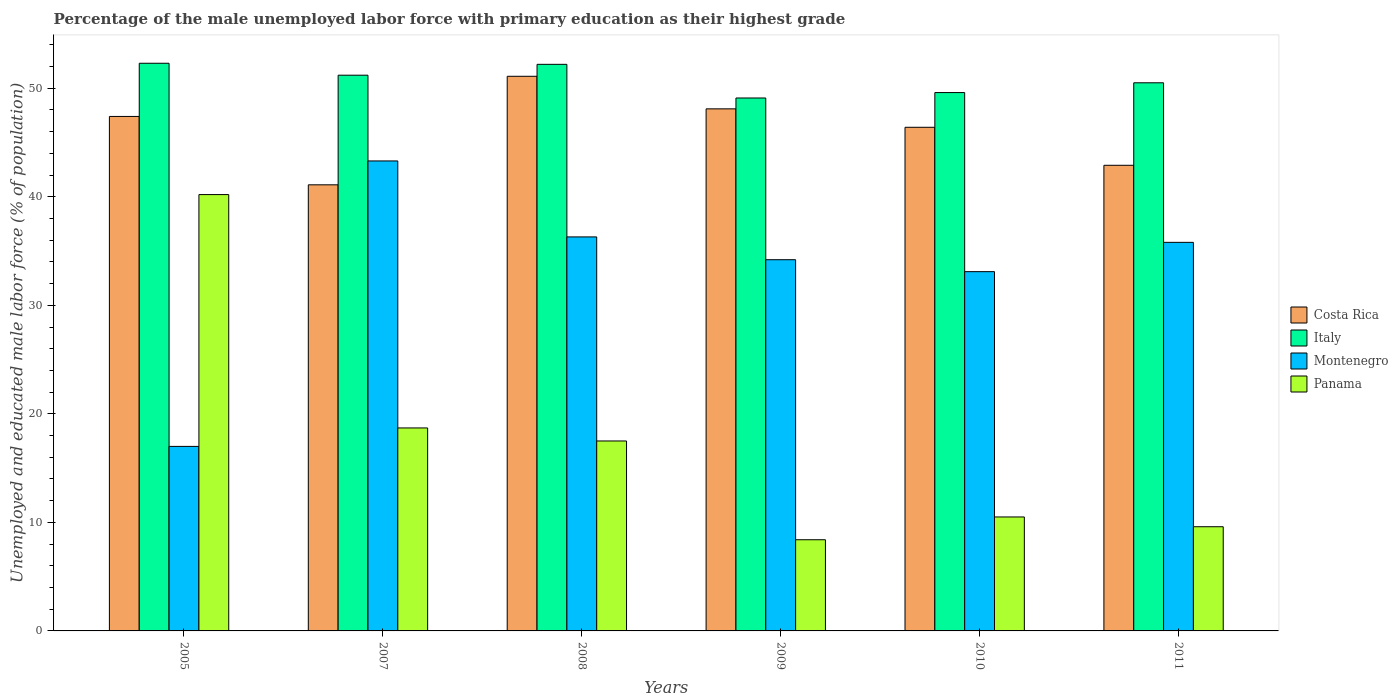How many different coloured bars are there?
Your answer should be compact. 4. How many groups of bars are there?
Your answer should be compact. 6. How many bars are there on the 2nd tick from the left?
Offer a very short reply. 4. What is the percentage of the unemployed male labor force with primary education in Italy in 2010?
Give a very brief answer. 49.6. Across all years, what is the maximum percentage of the unemployed male labor force with primary education in Montenegro?
Your answer should be compact. 43.3. Across all years, what is the minimum percentage of the unemployed male labor force with primary education in Montenegro?
Your answer should be very brief. 17. In which year was the percentage of the unemployed male labor force with primary education in Italy maximum?
Keep it short and to the point. 2005. What is the total percentage of the unemployed male labor force with primary education in Panama in the graph?
Your response must be concise. 104.9. What is the difference between the percentage of the unemployed male labor force with primary education in Panama in 2007 and that in 2008?
Provide a short and direct response. 1.2. What is the difference between the percentage of the unemployed male labor force with primary education in Panama in 2010 and the percentage of the unemployed male labor force with primary education in Italy in 2009?
Your answer should be very brief. -38.6. What is the average percentage of the unemployed male labor force with primary education in Montenegro per year?
Your answer should be very brief. 33.28. In the year 2009, what is the difference between the percentage of the unemployed male labor force with primary education in Italy and percentage of the unemployed male labor force with primary education in Costa Rica?
Your response must be concise. 1. In how many years, is the percentage of the unemployed male labor force with primary education in Panama greater than 34 %?
Keep it short and to the point. 1. What is the ratio of the percentage of the unemployed male labor force with primary education in Panama in 2010 to that in 2011?
Your answer should be compact. 1.09. What is the difference between the highest and the lowest percentage of the unemployed male labor force with primary education in Montenegro?
Give a very brief answer. 26.3. What does the 2nd bar from the left in 2009 represents?
Provide a short and direct response. Italy. How many bars are there?
Your response must be concise. 24. Are all the bars in the graph horizontal?
Provide a succinct answer. No. How many years are there in the graph?
Your response must be concise. 6. What is the difference between two consecutive major ticks on the Y-axis?
Ensure brevity in your answer.  10. Are the values on the major ticks of Y-axis written in scientific E-notation?
Your answer should be very brief. No. Does the graph contain grids?
Your response must be concise. No. How many legend labels are there?
Offer a terse response. 4. What is the title of the graph?
Provide a short and direct response. Percentage of the male unemployed labor force with primary education as their highest grade. What is the label or title of the X-axis?
Offer a very short reply. Years. What is the label or title of the Y-axis?
Provide a succinct answer. Unemployed and educated male labor force (% of population). What is the Unemployed and educated male labor force (% of population) in Costa Rica in 2005?
Offer a very short reply. 47.4. What is the Unemployed and educated male labor force (% of population) in Italy in 2005?
Your response must be concise. 52.3. What is the Unemployed and educated male labor force (% of population) in Montenegro in 2005?
Provide a short and direct response. 17. What is the Unemployed and educated male labor force (% of population) in Panama in 2005?
Your answer should be compact. 40.2. What is the Unemployed and educated male labor force (% of population) of Costa Rica in 2007?
Provide a short and direct response. 41.1. What is the Unemployed and educated male labor force (% of population) in Italy in 2007?
Give a very brief answer. 51.2. What is the Unemployed and educated male labor force (% of population) of Montenegro in 2007?
Provide a succinct answer. 43.3. What is the Unemployed and educated male labor force (% of population) of Panama in 2007?
Your answer should be very brief. 18.7. What is the Unemployed and educated male labor force (% of population) of Costa Rica in 2008?
Offer a terse response. 51.1. What is the Unemployed and educated male labor force (% of population) of Italy in 2008?
Your answer should be very brief. 52.2. What is the Unemployed and educated male labor force (% of population) in Montenegro in 2008?
Your answer should be compact. 36.3. What is the Unemployed and educated male labor force (% of population) of Costa Rica in 2009?
Provide a short and direct response. 48.1. What is the Unemployed and educated male labor force (% of population) of Italy in 2009?
Provide a short and direct response. 49.1. What is the Unemployed and educated male labor force (% of population) of Montenegro in 2009?
Offer a very short reply. 34.2. What is the Unemployed and educated male labor force (% of population) of Panama in 2009?
Offer a terse response. 8.4. What is the Unemployed and educated male labor force (% of population) of Costa Rica in 2010?
Provide a succinct answer. 46.4. What is the Unemployed and educated male labor force (% of population) in Italy in 2010?
Your answer should be very brief. 49.6. What is the Unemployed and educated male labor force (% of population) in Montenegro in 2010?
Ensure brevity in your answer.  33.1. What is the Unemployed and educated male labor force (% of population) of Panama in 2010?
Your answer should be very brief. 10.5. What is the Unemployed and educated male labor force (% of population) of Costa Rica in 2011?
Keep it short and to the point. 42.9. What is the Unemployed and educated male labor force (% of population) of Italy in 2011?
Give a very brief answer. 50.5. What is the Unemployed and educated male labor force (% of population) of Montenegro in 2011?
Keep it short and to the point. 35.8. What is the Unemployed and educated male labor force (% of population) of Panama in 2011?
Offer a terse response. 9.6. Across all years, what is the maximum Unemployed and educated male labor force (% of population) of Costa Rica?
Offer a terse response. 51.1. Across all years, what is the maximum Unemployed and educated male labor force (% of population) in Italy?
Your answer should be compact. 52.3. Across all years, what is the maximum Unemployed and educated male labor force (% of population) in Montenegro?
Offer a terse response. 43.3. Across all years, what is the maximum Unemployed and educated male labor force (% of population) in Panama?
Keep it short and to the point. 40.2. Across all years, what is the minimum Unemployed and educated male labor force (% of population) in Costa Rica?
Make the answer very short. 41.1. Across all years, what is the minimum Unemployed and educated male labor force (% of population) of Italy?
Offer a terse response. 49.1. Across all years, what is the minimum Unemployed and educated male labor force (% of population) in Montenegro?
Give a very brief answer. 17. Across all years, what is the minimum Unemployed and educated male labor force (% of population) in Panama?
Keep it short and to the point. 8.4. What is the total Unemployed and educated male labor force (% of population) in Costa Rica in the graph?
Offer a terse response. 277. What is the total Unemployed and educated male labor force (% of population) in Italy in the graph?
Offer a very short reply. 304.9. What is the total Unemployed and educated male labor force (% of population) of Montenegro in the graph?
Offer a terse response. 199.7. What is the total Unemployed and educated male labor force (% of population) of Panama in the graph?
Give a very brief answer. 104.9. What is the difference between the Unemployed and educated male labor force (% of population) in Montenegro in 2005 and that in 2007?
Provide a succinct answer. -26.3. What is the difference between the Unemployed and educated male labor force (% of population) in Italy in 2005 and that in 2008?
Ensure brevity in your answer.  0.1. What is the difference between the Unemployed and educated male labor force (% of population) in Montenegro in 2005 and that in 2008?
Offer a terse response. -19.3. What is the difference between the Unemployed and educated male labor force (% of population) in Panama in 2005 and that in 2008?
Give a very brief answer. 22.7. What is the difference between the Unemployed and educated male labor force (% of population) in Costa Rica in 2005 and that in 2009?
Your answer should be very brief. -0.7. What is the difference between the Unemployed and educated male labor force (% of population) of Italy in 2005 and that in 2009?
Your answer should be compact. 3.2. What is the difference between the Unemployed and educated male labor force (% of population) in Montenegro in 2005 and that in 2009?
Make the answer very short. -17.2. What is the difference between the Unemployed and educated male labor force (% of population) of Panama in 2005 and that in 2009?
Give a very brief answer. 31.8. What is the difference between the Unemployed and educated male labor force (% of population) of Italy in 2005 and that in 2010?
Offer a very short reply. 2.7. What is the difference between the Unemployed and educated male labor force (% of population) in Montenegro in 2005 and that in 2010?
Your answer should be very brief. -16.1. What is the difference between the Unemployed and educated male labor force (% of population) in Panama in 2005 and that in 2010?
Offer a very short reply. 29.7. What is the difference between the Unemployed and educated male labor force (% of population) in Costa Rica in 2005 and that in 2011?
Ensure brevity in your answer.  4.5. What is the difference between the Unemployed and educated male labor force (% of population) in Italy in 2005 and that in 2011?
Your answer should be very brief. 1.8. What is the difference between the Unemployed and educated male labor force (% of population) of Montenegro in 2005 and that in 2011?
Offer a terse response. -18.8. What is the difference between the Unemployed and educated male labor force (% of population) in Panama in 2005 and that in 2011?
Offer a terse response. 30.6. What is the difference between the Unemployed and educated male labor force (% of population) of Montenegro in 2007 and that in 2008?
Provide a short and direct response. 7. What is the difference between the Unemployed and educated male labor force (% of population) of Costa Rica in 2007 and that in 2010?
Offer a very short reply. -5.3. What is the difference between the Unemployed and educated male labor force (% of population) of Panama in 2007 and that in 2010?
Offer a very short reply. 8.2. What is the difference between the Unemployed and educated male labor force (% of population) of Costa Rica in 2008 and that in 2009?
Your answer should be very brief. 3. What is the difference between the Unemployed and educated male labor force (% of population) in Italy in 2008 and that in 2010?
Provide a succinct answer. 2.6. What is the difference between the Unemployed and educated male labor force (% of population) of Montenegro in 2008 and that in 2010?
Provide a short and direct response. 3.2. What is the difference between the Unemployed and educated male labor force (% of population) in Panama in 2008 and that in 2010?
Offer a terse response. 7. What is the difference between the Unemployed and educated male labor force (% of population) in Costa Rica in 2008 and that in 2011?
Provide a succinct answer. 8.2. What is the difference between the Unemployed and educated male labor force (% of population) in Costa Rica in 2009 and that in 2010?
Provide a succinct answer. 1.7. What is the difference between the Unemployed and educated male labor force (% of population) of Italy in 2009 and that in 2010?
Offer a very short reply. -0.5. What is the difference between the Unemployed and educated male labor force (% of population) of Montenegro in 2009 and that in 2010?
Keep it short and to the point. 1.1. What is the difference between the Unemployed and educated male labor force (% of population) of Panama in 2009 and that in 2010?
Offer a very short reply. -2.1. What is the difference between the Unemployed and educated male labor force (% of population) of Costa Rica in 2009 and that in 2011?
Provide a short and direct response. 5.2. What is the difference between the Unemployed and educated male labor force (% of population) in Italy in 2009 and that in 2011?
Provide a short and direct response. -1.4. What is the difference between the Unemployed and educated male labor force (% of population) in Montenegro in 2010 and that in 2011?
Offer a terse response. -2.7. What is the difference between the Unemployed and educated male labor force (% of population) in Costa Rica in 2005 and the Unemployed and educated male labor force (% of population) in Italy in 2007?
Provide a short and direct response. -3.8. What is the difference between the Unemployed and educated male labor force (% of population) of Costa Rica in 2005 and the Unemployed and educated male labor force (% of population) of Panama in 2007?
Give a very brief answer. 28.7. What is the difference between the Unemployed and educated male labor force (% of population) in Italy in 2005 and the Unemployed and educated male labor force (% of population) in Montenegro in 2007?
Make the answer very short. 9. What is the difference between the Unemployed and educated male labor force (% of population) of Italy in 2005 and the Unemployed and educated male labor force (% of population) of Panama in 2007?
Your response must be concise. 33.6. What is the difference between the Unemployed and educated male labor force (% of population) of Montenegro in 2005 and the Unemployed and educated male labor force (% of population) of Panama in 2007?
Your answer should be compact. -1.7. What is the difference between the Unemployed and educated male labor force (% of population) of Costa Rica in 2005 and the Unemployed and educated male labor force (% of population) of Italy in 2008?
Give a very brief answer. -4.8. What is the difference between the Unemployed and educated male labor force (% of population) in Costa Rica in 2005 and the Unemployed and educated male labor force (% of population) in Panama in 2008?
Your answer should be compact. 29.9. What is the difference between the Unemployed and educated male labor force (% of population) of Italy in 2005 and the Unemployed and educated male labor force (% of population) of Montenegro in 2008?
Provide a short and direct response. 16. What is the difference between the Unemployed and educated male labor force (% of population) in Italy in 2005 and the Unemployed and educated male labor force (% of population) in Panama in 2008?
Provide a short and direct response. 34.8. What is the difference between the Unemployed and educated male labor force (% of population) of Montenegro in 2005 and the Unemployed and educated male labor force (% of population) of Panama in 2008?
Your answer should be compact. -0.5. What is the difference between the Unemployed and educated male labor force (% of population) in Costa Rica in 2005 and the Unemployed and educated male labor force (% of population) in Italy in 2009?
Provide a short and direct response. -1.7. What is the difference between the Unemployed and educated male labor force (% of population) in Costa Rica in 2005 and the Unemployed and educated male labor force (% of population) in Panama in 2009?
Provide a succinct answer. 39. What is the difference between the Unemployed and educated male labor force (% of population) in Italy in 2005 and the Unemployed and educated male labor force (% of population) in Panama in 2009?
Keep it short and to the point. 43.9. What is the difference between the Unemployed and educated male labor force (% of population) of Montenegro in 2005 and the Unemployed and educated male labor force (% of population) of Panama in 2009?
Your response must be concise. 8.6. What is the difference between the Unemployed and educated male labor force (% of population) of Costa Rica in 2005 and the Unemployed and educated male labor force (% of population) of Italy in 2010?
Provide a short and direct response. -2.2. What is the difference between the Unemployed and educated male labor force (% of population) in Costa Rica in 2005 and the Unemployed and educated male labor force (% of population) in Montenegro in 2010?
Make the answer very short. 14.3. What is the difference between the Unemployed and educated male labor force (% of population) of Costa Rica in 2005 and the Unemployed and educated male labor force (% of population) of Panama in 2010?
Offer a terse response. 36.9. What is the difference between the Unemployed and educated male labor force (% of population) in Italy in 2005 and the Unemployed and educated male labor force (% of population) in Montenegro in 2010?
Keep it short and to the point. 19.2. What is the difference between the Unemployed and educated male labor force (% of population) in Italy in 2005 and the Unemployed and educated male labor force (% of population) in Panama in 2010?
Your answer should be very brief. 41.8. What is the difference between the Unemployed and educated male labor force (% of population) in Montenegro in 2005 and the Unemployed and educated male labor force (% of population) in Panama in 2010?
Your answer should be very brief. 6.5. What is the difference between the Unemployed and educated male labor force (% of population) in Costa Rica in 2005 and the Unemployed and educated male labor force (% of population) in Italy in 2011?
Keep it short and to the point. -3.1. What is the difference between the Unemployed and educated male labor force (% of population) in Costa Rica in 2005 and the Unemployed and educated male labor force (% of population) in Montenegro in 2011?
Your answer should be very brief. 11.6. What is the difference between the Unemployed and educated male labor force (% of population) of Costa Rica in 2005 and the Unemployed and educated male labor force (% of population) of Panama in 2011?
Your response must be concise. 37.8. What is the difference between the Unemployed and educated male labor force (% of population) of Italy in 2005 and the Unemployed and educated male labor force (% of population) of Panama in 2011?
Your answer should be compact. 42.7. What is the difference between the Unemployed and educated male labor force (% of population) in Costa Rica in 2007 and the Unemployed and educated male labor force (% of population) in Italy in 2008?
Provide a succinct answer. -11.1. What is the difference between the Unemployed and educated male labor force (% of population) of Costa Rica in 2007 and the Unemployed and educated male labor force (% of population) of Panama in 2008?
Keep it short and to the point. 23.6. What is the difference between the Unemployed and educated male labor force (% of population) of Italy in 2007 and the Unemployed and educated male labor force (% of population) of Montenegro in 2008?
Make the answer very short. 14.9. What is the difference between the Unemployed and educated male labor force (% of population) in Italy in 2007 and the Unemployed and educated male labor force (% of population) in Panama in 2008?
Your response must be concise. 33.7. What is the difference between the Unemployed and educated male labor force (% of population) in Montenegro in 2007 and the Unemployed and educated male labor force (% of population) in Panama in 2008?
Provide a short and direct response. 25.8. What is the difference between the Unemployed and educated male labor force (% of population) of Costa Rica in 2007 and the Unemployed and educated male labor force (% of population) of Italy in 2009?
Your answer should be very brief. -8. What is the difference between the Unemployed and educated male labor force (% of population) in Costa Rica in 2007 and the Unemployed and educated male labor force (% of population) in Panama in 2009?
Offer a very short reply. 32.7. What is the difference between the Unemployed and educated male labor force (% of population) in Italy in 2007 and the Unemployed and educated male labor force (% of population) in Panama in 2009?
Provide a short and direct response. 42.8. What is the difference between the Unemployed and educated male labor force (% of population) in Montenegro in 2007 and the Unemployed and educated male labor force (% of population) in Panama in 2009?
Offer a terse response. 34.9. What is the difference between the Unemployed and educated male labor force (% of population) of Costa Rica in 2007 and the Unemployed and educated male labor force (% of population) of Montenegro in 2010?
Your answer should be compact. 8. What is the difference between the Unemployed and educated male labor force (% of population) of Costa Rica in 2007 and the Unemployed and educated male labor force (% of population) of Panama in 2010?
Provide a succinct answer. 30.6. What is the difference between the Unemployed and educated male labor force (% of population) in Italy in 2007 and the Unemployed and educated male labor force (% of population) in Panama in 2010?
Make the answer very short. 40.7. What is the difference between the Unemployed and educated male labor force (% of population) of Montenegro in 2007 and the Unemployed and educated male labor force (% of population) of Panama in 2010?
Keep it short and to the point. 32.8. What is the difference between the Unemployed and educated male labor force (% of population) of Costa Rica in 2007 and the Unemployed and educated male labor force (% of population) of Panama in 2011?
Keep it short and to the point. 31.5. What is the difference between the Unemployed and educated male labor force (% of population) of Italy in 2007 and the Unemployed and educated male labor force (% of population) of Montenegro in 2011?
Your response must be concise. 15.4. What is the difference between the Unemployed and educated male labor force (% of population) of Italy in 2007 and the Unemployed and educated male labor force (% of population) of Panama in 2011?
Give a very brief answer. 41.6. What is the difference between the Unemployed and educated male labor force (% of population) of Montenegro in 2007 and the Unemployed and educated male labor force (% of population) of Panama in 2011?
Your answer should be very brief. 33.7. What is the difference between the Unemployed and educated male labor force (% of population) in Costa Rica in 2008 and the Unemployed and educated male labor force (% of population) in Panama in 2009?
Provide a short and direct response. 42.7. What is the difference between the Unemployed and educated male labor force (% of population) in Italy in 2008 and the Unemployed and educated male labor force (% of population) in Panama in 2009?
Provide a short and direct response. 43.8. What is the difference between the Unemployed and educated male labor force (% of population) of Montenegro in 2008 and the Unemployed and educated male labor force (% of population) of Panama in 2009?
Ensure brevity in your answer.  27.9. What is the difference between the Unemployed and educated male labor force (% of population) in Costa Rica in 2008 and the Unemployed and educated male labor force (% of population) in Italy in 2010?
Your answer should be very brief. 1.5. What is the difference between the Unemployed and educated male labor force (% of population) in Costa Rica in 2008 and the Unemployed and educated male labor force (% of population) in Montenegro in 2010?
Give a very brief answer. 18. What is the difference between the Unemployed and educated male labor force (% of population) of Costa Rica in 2008 and the Unemployed and educated male labor force (% of population) of Panama in 2010?
Your answer should be very brief. 40.6. What is the difference between the Unemployed and educated male labor force (% of population) of Italy in 2008 and the Unemployed and educated male labor force (% of population) of Panama in 2010?
Make the answer very short. 41.7. What is the difference between the Unemployed and educated male labor force (% of population) of Montenegro in 2008 and the Unemployed and educated male labor force (% of population) of Panama in 2010?
Make the answer very short. 25.8. What is the difference between the Unemployed and educated male labor force (% of population) of Costa Rica in 2008 and the Unemployed and educated male labor force (% of population) of Montenegro in 2011?
Make the answer very short. 15.3. What is the difference between the Unemployed and educated male labor force (% of population) of Costa Rica in 2008 and the Unemployed and educated male labor force (% of population) of Panama in 2011?
Keep it short and to the point. 41.5. What is the difference between the Unemployed and educated male labor force (% of population) of Italy in 2008 and the Unemployed and educated male labor force (% of population) of Montenegro in 2011?
Your answer should be very brief. 16.4. What is the difference between the Unemployed and educated male labor force (% of population) in Italy in 2008 and the Unemployed and educated male labor force (% of population) in Panama in 2011?
Keep it short and to the point. 42.6. What is the difference between the Unemployed and educated male labor force (% of population) in Montenegro in 2008 and the Unemployed and educated male labor force (% of population) in Panama in 2011?
Your answer should be very brief. 26.7. What is the difference between the Unemployed and educated male labor force (% of population) of Costa Rica in 2009 and the Unemployed and educated male labor force (% of population) of Panama in 2010?
Your response must be concise. 37.6. What is the difference between the Unemployed and educated male labor force (% of population) of Italy in 2009 and the Unemployed and educated male labor force (% of population) of Montenegro in 2010?
Keep it short and to the point. 16. What is the difference between the Unemployed and educated male labor force (% of population) in Italy in 2009 and the Unemployed and educated male labor force (% of population) in Panama in 2010?
Provide a succinct answer. 38.6. What is the difference between the Unemployed and educated male labor force (% of population) in Montenegro in 2009 and the Unemployed and educated male labor force (% of population) in Panama in 2010?
Your answer should be very brief. 23.7. What is the difference between the Unemployed and educated male labor force (% of population) in Costa Rica in 2009 and the Unemployed and educated male labor force (% of population) in Montenegro in 2011?
Ensure brevity in your answer.  12.3. What is the difference between the Unemployed and educated male labor force (% of population) in Costa Rica in 2009 and the Unemployed and educated male labor force (% of population) in Panama in 2011?
Your answer should be very brief. 38.5. What is the difference between the Unemployed and educated male labor force (% of population) of Italy in 2009 and the Unemployed and educated male labor force (% of population) of Montenegro in 2011?
Provide a short and direct response. 13.3. What is the difference between the Unemployed and educated male labor force (% of population) of Italy in 2009 and the Unemployed and educated male labor force (% of population) of Panama in 2011?
Provide a succinct answer. 39.5. What is the difference between the Unemployed and educated male labor force (% of population) in Montenegro in 2009 and the Unemployed and educated male labor force (% of population) in Panama in 2011?
Ensure brevity in your answer.  24.6. What is the difference between the Unemployed and educated male labor force (% of population) in Costa Rica in 2010 and the Unemployed and educated male labor force (% of population) in Italy in 2011?
Your answer should be compact. -4.1. What is the difference between the Unemployed and educated male labor force (% of population) of Costa Rica in 2010 and the Unemployed and educated male labor force (% of population) of Montenegro in 2011?
Keep it short and to the point. 10.6. What is the difference between the Unemployed and educated male labor force (% of population) in Costa Rica in 2010 and the Unemployed and educated male labor force (% of population) in Panama in 2011?
Provide a succinct answer. 36.8. What is the difference between the Unemployed and educated male labor force (% of population) in Montenegro in 2010 and the Unemployed and educated male labor force (% of population) in Panama in 2011?
Your response must be concise. 23.5. What is the average Unemployed and educated male labor force (% of population) in Costa Rica per year?
Your answer should be very brief. 46.17. What is the average Unemployed and educated male labor force (% of population) of Italy per year?
Offer a very short reply. 50.82. What is the average Unemployed and educated male labor force (% of population) of Montenegro per year?
Your answer should be very brief. 33.28. What is the average Unemployed and educated male labor force (% of population) in Panama per year?
Provide a short and direct response. 17.48. In the year 2005, what is the difference between the Unemployed and educated male labor force (% of population) in Costa Rica and Unemployed and educated male labor force (% of population) in Montenegro?
Keep it short and to the point. 30.4. In the year 2005, what is the difference between the Unemployed and educated male labor force (% of population) in Italy and Unemployed and educated male labor force (% of population) in Montenegro?
Your answer should be very brief. 35.3. In the year 2005, what is the difference between the Unemployed and educated male labor force (% of population) of Montenegro and Unemployed and educated male labor force (% of population) of Panama?
Keep it short and to the point. -23.2. In the year 2007, what is the difference between the Unemployed and educated male labor force (% of population) in Costa Rica and Unemployed and educated male labor force (% of population) in Italy?
Ensure brevity in your answer.  -10.1. In the year 2007, what is the difference between the Unemployed and educated male labor force (% of population) in Costa Rica and Unemployed and educated male labor force (% of population) in Montenegro?
Offer a very short reply. -2.2. In the year 2007, what is the difference between the Unemployed and educated male labor force (% of population) of Costa Rica and Unemployed and educated male labor force (% of population) of Panama?
Offer a terse response. 22.4. In the year 2007, what is the difference between the Unemployed and educated male labor force (% of population) in Italy and Unemployed and educated male labor force (% of population) in Montenegro?
Offer a very short reply. 7.9. In the year 2007, what is the difference between the Unemployed and educated male labor force (% of population) of Italy and Unemployed and educated male labor force (% of population) of Panama?
Ensure brevity in your answer.  32.5. In the year 2007, what is the difference between the Unemployed and educated male labor force (% of population) of Montenegro and Unemployed and educated male labor force (% of population) of Panama?
Ensure brevity in your answer.  24.6. In the year 2008, what is the difference between the Unemployed and educated male labor force (% of population) of Costa Rica and Unemployed and educated male labor force (% of population) of Italy?
Give a very brief answer. -1.1. In the year 2008, what is the difference between the Unemployed and educated male labor force (% of population) in Costa Rica and Unemployed and educated male labor force (% of population) in Panama?
Ensure brevity in your answer.  33.6. In the year 2008, what is the difference between the Unemployed and educated male labor force (% of population) of Italy and Unemployed and educated male labor force (% of population) of Montenegro?
Give a very brief answer. 15.9. In the year 2008, what is the difference between the Unemployed and educated male labor force (% of population) of Italy and Unemployed and educated male labor force (% of population) of Panama?
Offer a very short reply. 34.7. In the year 2008, what is the difference between the Unemployed and educated male labor force (% of population) in Montenegro and Unemployed and educated male labor force (% of population) in Panama?
Your response must be concise. 18.8. In the year 2009, what is the difference between the Unemployed and educated male labor force (% of population) in Costa Rica and Unemployed and educated male labor force (% of population) in Panama?
Provide a short and direct response. 39.7. In the year 2009, what is the difference between the Unemployed and educated male labor force (% of population) in Italy and Unemployed and educated male labor force (% of population) in Panama?
Offer a terse response. 40.7. In the year 2009, what is the difference between the Unemployed and educated male labor force (% of population) in Montenegro and Unemployed and educated male labor force (% of population) in Panama?
Ensure brevity in your answer.  25.8. In the year 2010, what is the difference between the Unemployed and educated male labor force (% of population) in Costa Rica and Unemployed and educated male labor force (% of population) in Montenegro?
Provide a succinct answer. 13.3. In the year 2010, what is the difference between the Unemployed and educated male labor force (% of population) in Costa Rica and Unemployed and educated male labor force (% of population) in Panama?
Make the answer very short. 35.9. In the year 2010, what is the difference between the Unemployed and educated male labor force (% of population) of Italy and Unemployed and educated male labor force (% of population) of Panama?
Provide a succinct answer. 39.1. In the year 2010, what is the difference between the Unemployed and educated male labor force (% of population) of Montenegro and Unemployed and educated male labor force (% of population) of Panama?
Your answer should be very brief. 22.6. In the year 2011, what is the difference between the Unemployed and educated male labor force (% of population) in Costa Rica and Unemployed and educated male labor force (% of population) in Italy?
Keep it short and to the point. -7.6. In the year 2011, what is the difference between the Unemployed and educated male labor force (% of population) in Costa Rica and Unemployed and educated male labor force (% of population) in Panama?
Ensure brevity in your answer.  33.3. In the year 2011, what is the difference between the Unemployed and educated male labor force (% of population) in Italy and Unemployed and educated male labor force (% of population) in Panama?
Offer a very short reply. 40.9. In the year 2011, what is the difference between the Unemployed and educated male labor force (% of population) of Montenegro and Unemployed and educated male labor force (% of population) of Panama?
Provide a succinct answer. 26.2. What is the ratio of the Unemployed and educated male labor force (% of population) in Costa Rica in 2005 to that in 2007?
Provide a succinct answer. 1.15. What is the ratio of the Unemployed and educated male labor force (% of population) in Italy in 2005 to that in 2007?
Keep it short and to the point. 1.02. What is the ratio of the Unemployed and educated male labor force (% of population) of Montenegro in 2005 to that in 2007?
Ensure brevity in your answer.  0.39. What is the ratio of the Unemployed and educated male labor force (% of population) in Panama in 2005 to that in 2007?
Your answer should be compact. 2.15. What is the ratio of the Unemployed and educated male labor force (% of population) of Costa Rica in 2005 to that in 2008?
Your answer should be very brief. 0.93. What is the ratio of the Unemployed and educated male labor force (% of population) in Italy in 2005 to that in 2008?
Offer a terse response. 1. What is the ratio of the Unemployed and educated male labor force (% of population) of Montenegro in 2005 to that in 2008?
Ensure brevity in your answer.  0.47. What is the ratio of the Unemployed and educated male labor force (% of population) in Panama in 2005 to that in 2008?
Your response must be concise. 2.3. What is the ratio of the Unemployed and educated male labor force (% of population) of Costa Rica in 2005 to that in 2009?
Your response must be concise. 0.99. What is the ratio of the Unemployed and educated male labor force (% of population) in Italy in 2005 to that in 2009?
Your answer should be very brief. 1.07. What is the ratio of the Unemployed and educated male labor force (% of population) of Montenegro in 2005 to that in 2009?
Make the answer very short. 0.5. What is the ratio of the Unemployed and educated male labor force (% of population) of Panama in 2005 to that in 2009?
Offer a terse response. 4.79. What is the ratio of the Unemployed and educated male labor force (% of population) of Costa Rica in 2005 to that in 2010?
Give a very brief answer. 1.02. What is the ratio of the Unemployed and educated male labor force (% of population) in Italy in 2005 to that in 2010?
Ensure brevity in your answer.  1.05. What is the ratio of the Unemployed and educated male labor force (% of population) in Montenegro in 2005 to that in 2010?
Your answer should be very brief. 0.51. What is the ratio of the Unemployed and educated male labor force (% of population) in Panama in 2005 to that in 2010?
Keep it short and to the point. 3.83. What is the ratio of the Unemployed and educated male labor force (% of population) in Costa Rica in 2005 to that in 2011?
Ensure brevity in your answer.  1.1. What is the ratio of the Unemployed and educated male labor force (% of population) in Italy in 2005 to that in 2011?
Provide a succinct answer. 1.04. What is the ratio of the Unemployed and educated male labor force (% of population) of Montenegro in 2005 to that in 2011?
Provide a short and direct response. 0.47. What is the ratio of the Unemployed and educated male labor force (% of population) in Panama in 2005 to that in 2011?
Your answer should be very brief. 4.19. What is the ratio of the Unemployed and educated male labor force (% of population) in Costa Rica in 2007 to that in 2008?
Make the answer very short. 0.8. What is the ratio of the Unemployed and educated male labor force (% of population) of Italy in 2007 to that in 2008?
Ensure brevity in your answer.  0.98. What is the ratio of the Unemployed and educated male labor force (% of population) of Montenegro in 2007 to that in 2008?
Make the answer very short. 1.19. What is the ratio of the Unemployed and educated male labor force (% of population) of Panama in 2007 to that in 2008?
Your answer should be compact. 1.07. What is the ratio of the Unemployed and educated male labor force (% of population) in Costa Rica in 2007 to that in 2009?
Your answer should be compact. 0.85. What is the ratio of the Unemployed and educated male labor force (% of population) in Italy in 2007 to that in 2009?
Ensure brevity in your answer.  1.04. What is the ratio of the Unemployed and educated male labor force (% of population) of Montenegro in 2007 to that in 2009?
Make the answer very short. 1.27. What is the ratio of the Unemployed and educated male labor force (% of population) of Panama in 2007 to that in 2009?
Keep it short and to the point. 2.23. What is the ratio of the Unemployed and educated male labor force (% of population) of Costa Rica in 2007 to that in 2010?
Your answer should be very brief. 0.89. What is the ratio of the Unemployed and educated male labor force (% of population) in Italy in 2007 to that in 2010?
Give a very brief answer. 1.03. What is the ratio of the Unemployed and educated male labor force (% of population) in Montenegro in 2007 to that in 2010?
Your answer should be very brief. 1.31. What is the ratio of the Unemployed and educated male labor force (% of population) in Panama in 2007 to that in 2010?
Your answer should be very brief. 1.78. What is the ratio of the Unemployed and educated male labor force (% of population) of Costa Rica in 2007 to that in 2011?
Provide a succinct answer. 0.96. What is the ratio of the Unemployed and educated male labor force (% of population) of Italy in 2007 to that in 2011?
Make the answer very short. 1.01. What is the ratio of the Unemployed and educated male labor force (% of population) in Montenegro in 2007 to that in 2011?
Keep it short and to the point. 1.21. What is the ratio of the Unemployed and educated male labor force (% of population) in Panama in 2007 to that in 2011?
Offer a very short reply. 1.95. What is the ratio of the Unemployed and educated male labor force (% of population) in Costa Rica in 2008 to that in 2009?
Offer a terse response. 1.06. What is the ratio of the Unemployed and educated male labor force (% of population) of Italy in 2008 to that in 2009?
Keep it short and to the point. 1.06. What is the ratio of the Unemployed and educated male labor force (% of population) of Montenegro in 2008 to that in 2009?
Provide a short and direct response. 1.06. What is the ratio of the Unemployed and educated male labor force (% of population) of Panama in 2008 to that in 2009?
Keep it short and to the point. 2.08. What is the ratio of the Unemployed and educated male labor force (% of population) in Costa Rica in 2008 to that in 2010?
Offer a very short reply. 1.1. What is the ratio of the Unemployed and educated male labor force (% of population) in Italy in 2008 to that in 2010?
Give a very brief answer. 1.05. What is the ratio of the Unemployed and educated male labor force (% of population) in Montenegro in 2008 to that in 2010?
Offer a very short reply. 1.1. What is the ratio of the Unemployed and educated male labor force (% of population) of Panama in 2008 to that in 2010?
Your answer should be compact. 1.67. What is the ratio of the Unemployed and educated male labor force (% of population) in Costa Rica in 2008 to that in 2011?
Your answer should be very brief. 1.19. What is the ratio of the Unemployed and educated male labor force (% of population) in Italy in 2008 to that in 2011?
Make the answer very short. 1.03. What is the ratio of the Unemployed and educated male labor force (% of population) in Montenegro in 2008 to that in 2011?
Make the answer very short. 1.01. What is the ratio of the Unemployed and educated male labor force (% of population) of Panama in 2008 to that in 2011?
Make the answer very short. 1.82. What is the ratio of the Unemployed and educated male labor force (% of population) of Costa Rica in 2009 to that in 2010?
Offer a terse response. 1.04. What is the ratio of the Unemployed and educated male labor force (% of population) of Montenegro in 2009 to that in 2010?
Your response must be concise. 1.03. What is the ratio of the Unemployed and educated male labor force (% of population) of Panama in 2009 to that in 2010?
Offer a terse response. 0.8. What is the ratio of the Unemployed and educated male labor force (% of population) of Costa Rica in 2009 to that in 2011?
Give a very brief answer. 1.12. What is the ratio of the Unemployed and educated male labor force (% of population) of Italy in 2009 to that in 2011?
Your answer should be compact. 0.97. What is the ratio of the Unemployed and educated male labor force (% of population) of Montenegro in 2009 to that in 2011?
Keep it short and to the point. 0.96. What is the ratio of the Unemployed and educated male labor force (% of population) of Costa Rica in 2010 to that in 2011?
Your response must be concise. 1.08. What is the ratio of the Unemployed and educated male labor force (% of population) of Italy in 2010 to that in 2011?
Provide a succinct answer. 0.98. What is the ratio of the Unemployed and educated male labor force (% of population) in Montenegro in 2010 to that in 2011?
Provide a succinct answer. 0.92. What is the ratio of the Unemployed and educated male labor force (% of population) of Panama in 2010 to that in 2011?
Your response must be concise. 1.09. What is the difference between the highest and the second highest Unemployed and educated male labor force (% of population) of Costa Rica?
Offer a very short reply. 3. What is the difference between the highest and the second highest Unemployed and educated male labor force (% of population) in Italy?
Your answer should be very brief. 0.1. What is the difference between the highest and the lowest Unemployed and educated male labor force (% of population) of Montenegro?
Make the answer very short. 26.3. What is the difference between the highest and the lowest Unemployed and educated male labor force (% of population) of Panama?
Keep it short and to the point. 31.8. 